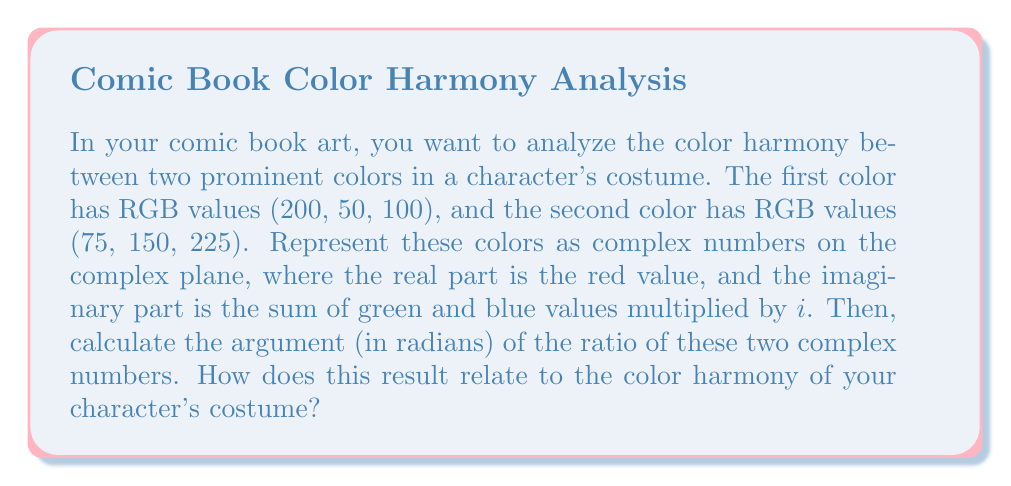What is the answer to this math problem? Let's approach this step-by-step:

1) First, we need to represent the colors as complex numbers:

   Color 1: $z_1 = 200 + (50 + 100)i = 200 + 150i$
   Color 2: $z_2 = 75 + (150 + 225)i = 75 + 375i$

2) We need to find the ratio of these complex numbers:

   $$\frac{z_1}{z_2} = \frac{200 + 150i}{75 + 375i}$$

3) To calculate the argument of this ratio, we can multiply by the complex conjugate of the denominator:

   $$\frac{z_1}{z_2} \cdot \frac{75 - 375i}{75 - 375i} = \frac{(200 + 150i)(75 - 375i)}{75^2 + 375^2}$$

4) Expanding the numerator:

   $$\frac{15000 - 75000i + 11250i + 56250}{75^2 + 375^2} = \frac{71250 - 63750i}{146250}$$

5) Simplifying:

   $$\frac{71250}{146250} - \frac{63750}{146250}i = \frac{13}{27} - \frac{25}{54}i$$

6) Now we can calculate the argument using the arctangent function:

   $$\arg\left(\frac{z_1}{z_2}\right) = \arctan\left(-\frac{25/54}{13/27}\right) = \arctan\left(-\frac{25}{26}\right)$$

7) Evaluating this:

   $$\arg\left(\frac{z_1}{z_2}\right) \approx -0.7648 \text{ radians}$$

This result relates to the color harmony of your character's costume in the following way:

- The argument of the ratio represents the angular difference between the two colors in this complex representation.
- A value close to 0 or π would indicate colors that are more harmonious (either similar or complementary).
- The result of about -0.7648 radians (or about -43.8 degrees) suggests a moderate level of contrast between the two colors, which could create visual interest without being too jarring.
Answer: The argument of the ratio of the two complex numbers representing the colors is approximately -0.7648 radians. 